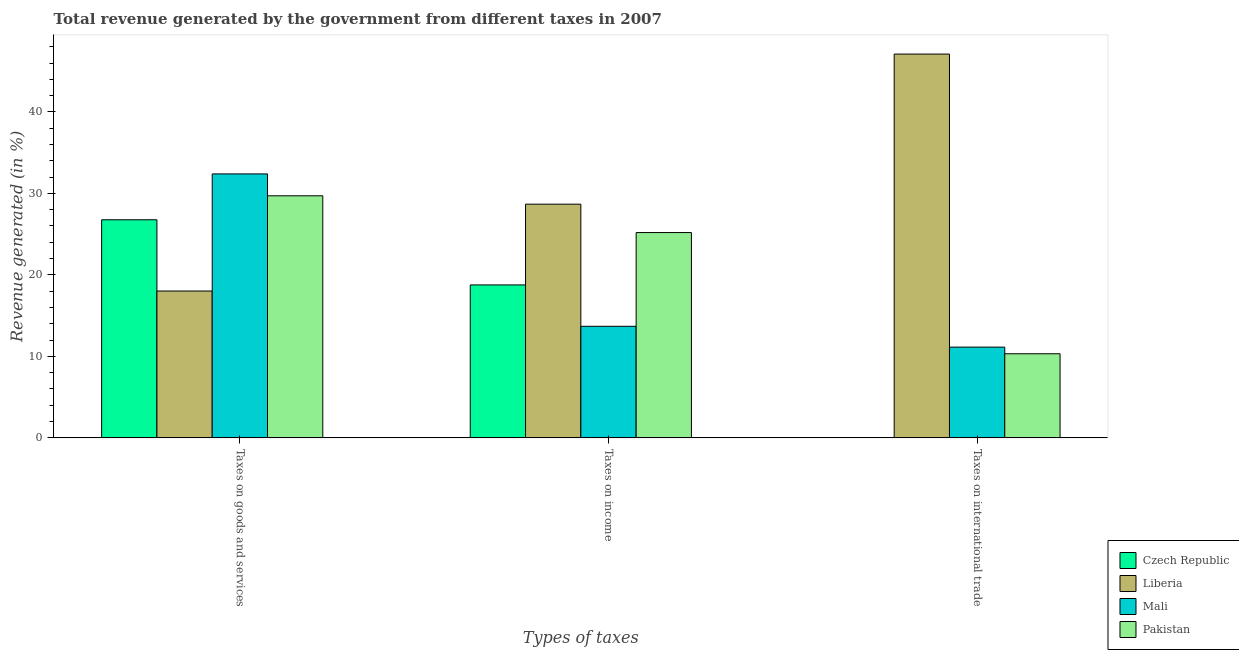How many groups of bars are there?
Give a very brief answer. 3. Are the number of bars per tick equal to the number of legend labels?
Ensure brevity in your answer.  Yes. Are the number of bars on each tick of the X-axis equal?
Ensure brevity in your answer.  Yes. How many bars are there on the 2nd tick from the left?
Provide a succinct answer. 4. How many bars are there on the 2nd tick from the right?
Give a very brief answer. 4. What is the label of the 1st group of bars from the left?
Offer a terse response. Taxes on goods and services. What is the percentage of revenue generated by taxes on income in Czech Republic?
Provide a short and direct response. 18.77. Across all countries, what is the maximum percentage of revenue generated by taxes on goods and services?
Your answer should be very brief. 32.39. Across all countries, what is the minimum percentage of revenue generated by tax on international trade?
Your response must be concise. 0. In which country was the percentage of revenue generated by taxes on goods and services maximum?
Give a very brief answer. Mali. In which country was the percentage of revenue generated by tax on international trade minimum?
Offer a terse response. Czech Republic. What is the total percentage of revenue generated by taxes on income in the graph?
Offer a very short reply. 86.33. What is the difference between the percentage of revenue generated by taxes on goods and services in Liberia and that in Czech Republic?
Provide a short and direct response. -8.74. What is the difference between the percentage of revenue generated by taxes on income in Mali and the percentage of revenue generated by tax on international trade in Czech Republic?
Ensure brevity in your answer.  13.69. What is the average percentage of revenue generated by tax on international trade per country?
Keep it short and to the point. 17.14. What is the difference between the percentage of revenue generated by taxes on income and percentage of revenue generated by tax on international trade in Liberia?
Offer a terse response. -18.42. In how many countries, is the percentage of revenue generated by taxes on goods and services greater than 6 %?
Provide a short and direct response. 4. What is the ratio of the percentage of revenue generated by taxes on income in Liberia to that in Mali?
Your response must be concise. 2.09. Is the percentage of revenue generated by taxes on goods and services in Liberia less than that in Pakistan?
Your answer should be compact. Yes. Is the difference between the percentage of revenue generated by taxes on goods and services in Liberia and Mali greater than the difference between the percentage of revenue generated by taxes on income in Liberia and Mali?
Your response must be concise. No. What is the difference between the highest and the second highest percentage of revenue generated by tax on international trade?
Give a very brief answer. 35.96. What is the difference between the highest and the lowest percentage of revenue generated by taxes on income?
Provide a succinct answer. 14.99. What does the 3rd bar from the left in Taxes on goods and services represents?
Your response must be concise. Mali. What does the 3rd bar from the right in Taxes on international trade represents?
Offer a terse response. Liberia. Is it the case that in every country, the sum of the percentage of revenue generated by taxes on goods and services and percentage of revenue generated by taxes on income is greater than the percentage of revenue generated by tax on international trade?
Give a very brief answer. No. Are all the bars in the graph horizontal?
Give a very brief answer. No. Does the graph contain any zero values?
Keep it short and to the point. No. What is the title of the graph?
Your response must be concise. Total revenue generated by the government from different taxes in 2007. Does "Sweden" appear as one of the legend labels in the graph?
Your response must be concise. No. What is the label or title of the X-axis?
Your answer should be very brief. Types of taxes. What is the label or title of the Y-axis?
Make the answer very short. Revenue generated (in %). What is the Revenue generated (in %) in Czech Republic in Taxes on goods and services?
Your answer should be compact. 26.76. What is the Revenue generated (in %) of Liberia in Taxes on goods and services?
Your response must be concise. 18.02. What is the Revenue generated (in %) in Mali in Taxes on goods and services?
Provide a short and direct response. 32.39. What is the Revenue generated (in %) of Pakistan in Taxes on goods and services?
Your response must be concise. 29.7. What is the Revenue generated (in %) in Czech Republic in Taxes on income?
Your answer should be compact. 18.77. What is the Revenue generated (in %) in Liberia in Taxes on income?
Make the answer very short. 28.68. What is the Revenue generated (in %) of Mali in Taxes on income?
Provide a short and direct response. 13.69. What is the Revenue generated (in %) of Pakistan in Taxes on income?
Offer a very short reply. 25.2. What is the Revenue generated (in %) in Czech Republic in Taxes on international trade?
Give a very brief answer. 0. What is the Revenue generated (in %) of Liberia in Taxes on international trade?
Provide a short and direct response. 47.1. What is the Revenue generated (in %) in Mali in Taxes on international trade?
Make the answer very short. 11.14. What is the Revenue generated (in %) of Pakistan in Taxes on international trade?
Give a very brief answer. 10.32. Across all Types of taxes, what is the maximum Revenue generated (in %) in Czech Republic?
Your answer should be very brief. 26.76. Across all Types of taxes, what is the maximum Revenue generated (in %) of Liberia?
Your response must be concise. 47.1. Across all Types of taxes, what is the maximum Revenue generated (in %) of Mali?
Your answer should be compact. 32.39. Across all Types of taxes, what is the maximum Revenue generated (in %) in Pakistan?
Keep it short and to the point. 29.7. Across all Types of taxes, what is the minimum Revenue generated (in %) of Czech Republic?
Provide a succinct answer. 0. Across all Types of taxes, what is the minimum Revenue generated (in %) in Liberia?
Provide a succinct answer. 18.02. Across all Types of taxes, what is the minimum Revenue generated (in %) of Mali?
Offer a terse response. 11.14. Across all Types of taxes, what is the minimum Revenue generated (in %) in Pakistan?
Your response must be concise. 10.32. What is the total Revenue generated (in %) of Czech Republic in the graph?
Provide a short and direct response. 45.54. What is the total Revenue generated (in %) in Liberia in the graph?
Provide a succinct answer. 93.8. What is the total Revenue generated (in %) in Mali in the graph?
Make the answer very short. 57.22. What is the total Revenue generated (in %) in Pakistan in the graph?
Your answer should be very brief. 65.22. What is the difference between the Revenue generated (in %) of Czech Republic in Taxes on goods and services and that in Taxes on income?
Keep it short and to the point. 8. What is the difference between the Revenue generated (in %) of Liberia in Taxes on goods and services and that in Taxes on income?
Give a very brief answer. -10.66. What is the difference between the Revenue generated (in %) of Mali in Taxes on goods and services and that in Taxes on income?
Give a very brief answer. 18.7. What is the difference between the Revenue generated (in %) of Pakistan in Taxes on goods and services and that in Taxes on income?
Your response must be concise. 4.51. What is the difference between the Revenue generated (in %) of Czech Republic in Taxes on goods and services and that in Taxes on international trade?
Give a very brief answer. 26.76. What is the difference between the Revenue generated (in %) of Liberia in Taxes on goods and services and that in Taxes on international trade?
Your answer should be compact. -29.08. What is the difference between the Revenue generated (in %) of Mali in Taxes on goods and services and that in Taxes on international trade?
Your answer should be very brief. 21.26. What is the difference between the Revenue generated (in %) in Pakistan in Taxes on goods and services and that in Taxes on international trade?
Ensure brevity in your answer.  19.38. What is the difference between the Revenue generated (in %) in Czech Republic in Taxes on income and that in Taxes on international trade?
Your response must be concise. 18.77. What is the difference between the Revenue generated (in %) of Liberia in Taxes on income and that in Taxes on international trade?
Provide a succinct answer. -18.42. What is the difference between the Revenue generated (in %) in Mali in Taxes on income and that in Taxes on international trade?
Ensure brevity in your answer.  2.56. What is the difference between the Revenue generated (in %) of Pakistan in Taxes on income and that in Taxes on international trade?
Make the answer very short. 14.87. What is the difference between the Revenue generated (in %) in Czech Republic in Taxes on goods and services and the Revenue generated (in %) in Liberia in Taxes on income?
Give a very brief answer. -1.91. What is the difference between the Revenue generated (in %) of Czech Republic in Taxes on goods and services and the Revenue generated (in %) of Mali in Taxes on income?
Ensure brevity in your answer.  13.07. What is the difference between the Revenue generated (in %) of Czech Republic in Taxes on goods and services and the Revenue generated (in %) of Pakistan in Taxes on income?
Offer a terse response. 1.57. What is the difference between the Revenue generated (in %) in Liberia in Taxes on goods and services and the Revenue generated (in %) in Mali in Taxes on income?
Your answer should be very brief. 4.33. What is the difference between the Revenue generated (in %) in Liberia in Taxes on goods and services and the Revenue generated (in %) in Pakistan in Taxes on income?
Your answer should be compact. -7.18. What is the difference between the Revenue generated (in %) of Mali in Taxes on goods and services and the Revenue generated (in %) of Pakistan in Taxes on income?
Your answer should be compact. 7.2. What is the difference between the Revenue generated (in %) of Czech Republic in Taxes on goods and services and the Revenue generated (in %) of Liberia in Taxes on international trade?
Offer a terse response. -20.33. What is the difference between the Revenue generated (in %) of Czech Republic in Taxes on goods and services and the Revenue generated (in %) of Mali in Taxes on international trade?
Offer a terse response. 15.63. What is the difference between the Revenue generated (in %) in Czech Republic in Taxes on goods and services and the Revenue generated (in %) in Pakistan in Taxes on international trade?
Your answer should be very brief. 16.44. What is the difference between the Revenue generated (in %) in Liberia in Taxes on goods and services and the Revenue generated (in %) in Mali in Taxes on international trade?
Provide a succinct answer. 6.88. What is the difference between the Revenue generated (in %) of Liberia in Taxes on goods and services and the Revenue generated (in %) of Pakistan in Taxes on international trade?
Make the answer very short. 7.7. What is the difference between the Revenue generated (in %) in Mali in Taxes on goods and services and the Revenue generated (in %) in Pakistan in Taxes on international trade?
Keep it short and to the point. 22.07. What is the difference between the Revenue generated (in %) of Czech Republic in Taxes on income and the Revenue generated (in %) of Liberia in Taxes on international trade?
Offer a terse response. -28.33. What is the difference between the Revenue generated (in %) of Czech Republic in Taxes on income and the Revenue generated (in %) of Mali in Taxes on international trade?
Provide a succinct answer. 7.63. What is the difference between the Revenue generated (in %) of Czech Republic in Taxes on income and the Revenue generated (in %) of Pakistan in Taxes on international trade?
Your answer should be very brief. 8.45. What is the difference between the Revenue generated (in %) in Liberia in Taxes on income and the Revenue generated (in %) in Mali in Taxes on international trade?
Give a very brief answer. 17.54. What is the difference between the Revenue generated (in %) of Liberia in Taxes on income and the Revenue generated (in %) of Pakistan in Taxes on international trade?
Ensure brevity in your answer.  18.36. What is the difference between the Revenue generated (in %) in Mali in Taxes on income and the Revenue generated (in %) in Pakistan in Taxes on international trade?
Your answer should be very brief. 3.37. What is the average Revenue generated (in %) of Czech Republic per Types of taxes?
Your answer should be very brief. 15.18. What is the average Revenue generated (in %) of Liberia per Types of taxes?
Offer a terse response. 31.27. What is the average Revenue generated (in %) of Mali per Types of taxes?
Your response must be concise. 19.07. What is the average Revenue generated (in %) of Pakistan per Types of taxes?
Make the answer very short. 21.74. What is the difference between the Revenue generated (in %) of Czech Republic and Revenue generated (in %) of Liberia in Taxes on goods and services?
Give a very brief answer. 8.74. What is the difference between the Revenue generated (in %) in Czech Republic and Revenue generated (in %) in Mali in Taxes on goods and services?
Provide a succinct answer. -5.63. What is the difference between the Revenue generated (in %) in Czech Republic and Revenue generated (in %) in Pakistan in Taxes on goods and services?
Provide a short and direct response. -2.94. What is the difference between the Revenue generated (in %) of Liberia and Revenue generated (in %) of Mali in Taxes on goods and services?
Ensure brevity in your answer.  -14.37. What is the difference between the Revenue generated (in %) in Liberia and Revenue generated (in %) in Pakistan in Taxes on goods and services?
Give a very brief answer. -11.68. What is the difference between the Revenue generated (in %) of Mali and Revenue generated (in %) of Pakistan in Taxes on goods and services?
Give a very brief answer. 2.69. What is the difference between the Revenue generated (in %) of Czech Republic and Revenue generated (in %) of Liberia in Taxes on income?
Provide a short and direct response. -9.91. What is the difference between the Revenue generated (in %) of Czech Republic and Revenue generated (in %) of Mali in Taxes on income?
Offer a very short reply. 5.08. What is the difference between the Revenue generated (in %) of Czech Republic and Revenue generated (in %) of Pakistan in Taxes on income?
Make the answer very short. -6.43. What is the difference between the Revenue generated (in %) of Liberia and Revenue generated (in %) of Mali in Taxes on income?
Offer a terse response. 14.99. What is the difference between the Revenue generated (in %) of Liberia and Revenue generated (in %) of Pakistan in Taxes on income?
Offer a terse response. 3.48. What is the difference between the Revenue generated (in %) in Mali and Revenue generated (in %) in Pakistan in Taxes on income?
Ensure brevity in your answer.  -11.51. What is the difference between the Revenue generated (in %) of Czech Republic and Revenue generated (in %) of Liberia in Taxes on international trade?
Your answer should be very brief. -47.1. What is the difference between the Revenue generated (in %) in Czech Republic and Revenue generated (in %) in Mali in Taxes on international trade?
Offer a very short reply. -11.13. What is the difference between the Revenue generated (in %) in Czech Republic and Revenue generated (in %) in Pakistan in Taxes on international trade?
Your answer should be compact. -10.32. What is the difference between the Revenue generated (in %) in Liberia and Revenue generated (in %) in Mali in Taxes on international trade?
Keep it short and to the point. 35.96. What is the difference between the Revenue generated (in %) of Liberia and Revenue generated (in %) of Pakistan in Taxes on international trade?
Your answer should be very brief. 36.78. What is the difference between the Revenue generated (in %) in Mali and Revenue generated (in %) in Pakistan in Taxes on international trade?
Provide a short and direct response. 0.81. What is the ratio of the Revenue generated (in %) of Czech Republic in Taxes on goods and services to that in Taxes on income?
Your answer should be very brief. 1.43. What is the ratio of the Revenue generated (in %) in Liberia in Taxes on goods and services to that in Taxes on income?
Offer a very short reply. 0.63. What is the ratio of the Revenue generated (in %) in Mali in Taxes on goods and services to that in Taxes on income?
Offer a terse response. 2.37. What is the ratio of the Revenue generated (in %) in Pakistan in Taxes on goods and services to that in Taxes on income?
Offer a very short reply. 1.18. What is the ratio of the Revenue generated (in %) in Czech Republic in Taxes on goods and services to that in Taxes on international trade?
Ensure brevity in your answer.  1.29e+04. What is the ratio of the Revenue generated (in %) of Liberia in Taxes on goods and services to that in Taxes on international trade?
Make the answer very short. 0.38. What is the ratio of the Revenue generated (in %) of Mali in Taxes on goods and services to that in Taxes on international trade?
Make the answer very short. 2.91. What is the ratio of the Revenue generated (in %) in Pakistan in Taxes on goods and services to that in Taxes on international trade?
Keep it short and to the point. 2.88. What is the ratio of the Revenue generated (in %) in Czech Republic in Taxes on income to that in Taxes on international trade?
Offer a terse response. 9037.08. What is the ratio of the Revenue generated (in %) of Liberia in Taxes on income to that in Taxes on international trade?
Offer a terse response. 0.61. What is the ratio of the Revenue generated (in %) of Mali in Taxes on income to that in Taxes on international trade?
Provide a short and direct response. 1.23. What is the ratio of the Revenue generated (in %) of Pakistan in Taxes on income to that in Taxes on international trade?
Your answer should be compact. 2.44. What is the difference between the highest and the second highest Revenue generated (in %) in Czech Republic?
Provide a succinct answer. 8. What is the difference between the highest and the second highest Revenue generated (in %) in Liberia?
Your answer should be very brief. 18.42. What is the difference between the highest and the second highest Revenue generated (in %) of Mali?
Provide a short and direct response. 18.7. What is the difference between the highest and the second highest Revenue generated (in %) of Pakistan?
Ensure brevity in your answer.  4.51. What is the difference between the highest and the lowest Revenue generated (in %) of Czech Republic?
Your answer should be compact. 26.76. What is the difference between the highest and the lowest Revenue generated (in %) of Liberia?
Offer a terse response. 29.08. What is the difference between the highest and the lowest Revenue generated (in %) of Mali?
Ensure brevity in your answer.  21.26. What is the difference between the highest and the lowest Revenue generated (in %) in Pakistan?
Give a very brief answer. 19.38. 